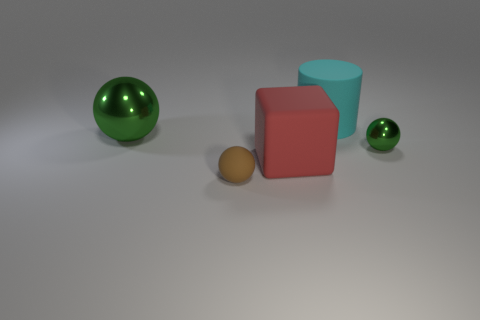What number of other things are the same color as the tiny metallic object?
Provide a succinct answer. 1. Do the brown object in front of the red block and the green sphere that is in front of the big green ball have the same material?
Provide a short and direct response. No. There is a thing that is on the left side of the tiny brown rubber object; how big is it?
Offer a terse response. Large. What is the material of the other small green object that is the same shape as the small rubber object?
Offer a very short reply. Metal. Is there anything else that has the same size as the block?
Your answer should be very brief. Yes. The big matte thing behind the tiny green metal ball has what shape?
Your answer should be compact. Cylinder. How many small metal objects are the same shape as the large green metallic object?
Ensure brevity in your answer.  1. Is the number of large objects on the left side of the large cylinder the same as the number of spheres in front of the big green metal object?
Provide a succinct answer. Yes. Are there any balls made of the same material as the cyan object?
Ensure brevity in your answer.  Yes. Do the large cyan object and the red thing have the same material?
Your response must be concise. Yes. 